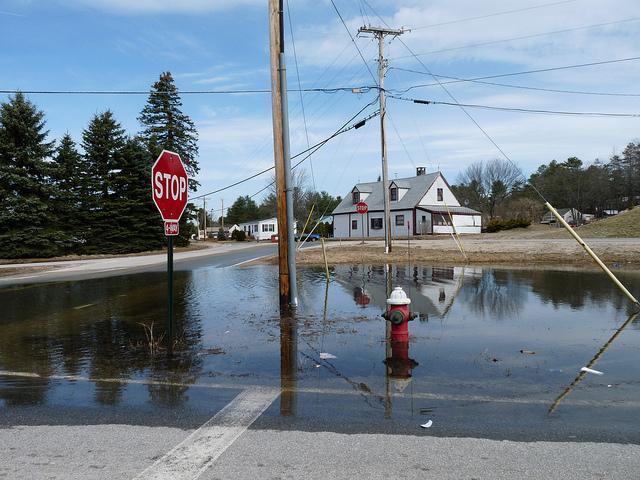How many stop signs are in the picture?
Give a very brief answer. 2. 